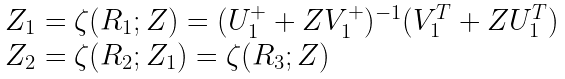Convert formula to latex. <formula><loc_0><loc_0><loc_500><loc_500>\begin{array} { l } Z _ { 1 } = \zeta ( R _ { 1 } ; Z ) = ( U _ { 1 } ^ { + } + Z V _ { 1 } ^ { + } ) ^ { - 1 } ( V _ { 1 } ^ { T } + Z U _ { 1 } ^ { T } ) \\ Z _ { 2 } = \zeta ( R _ { 2 } ; Z _ { 1 } ) = \zeta ( R _ { 3 } ; Z ) \end{array}</formula> 